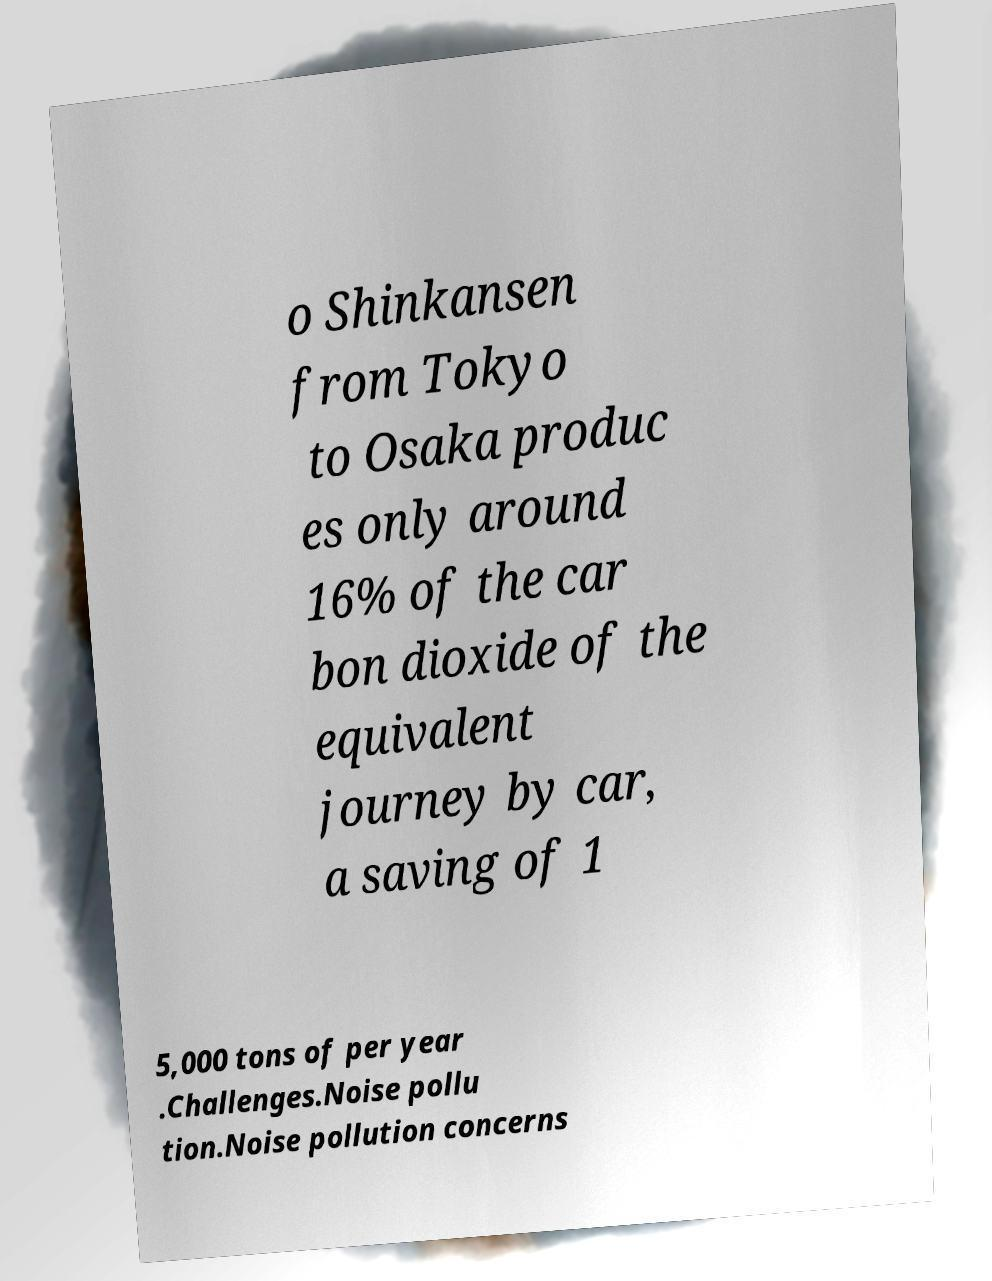Could you assist in decoding the text presented in this image and type it out clearly? o Shinkansen from Tokyo to Osaka produc es only around 16% of the car bon dioxide of the equivalent journey by car, a saving of 1 5,000 tons of per year .Challenges.Noise pollu tion.Noise pollution concerns 